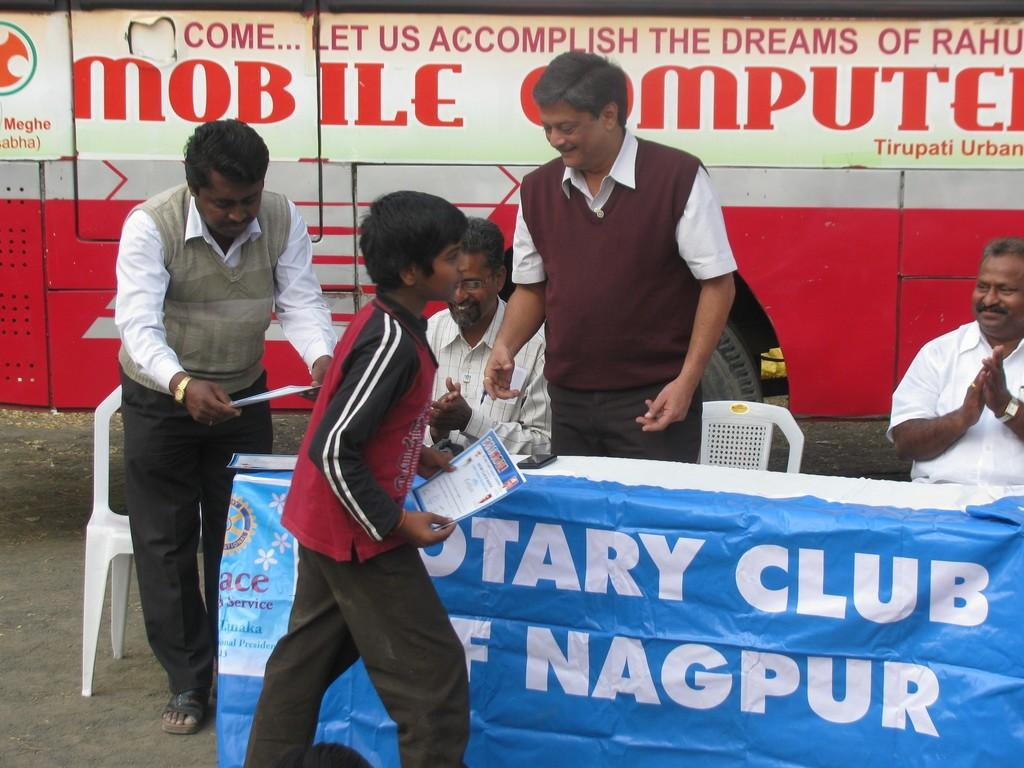What is the kid in the image doing? The kid is standing in the image and holding a certificate. Who else is present in the image? There are four persons beside the kid. What can be seen in the background of the image? There is a vehicle in the background of the image. What is written on the vehicle? The vehicle has something written on it. What type of surprise is the kid receiving from the vehicle in the image? There is no surprise present in the image; the kid is holding a certificate, and the vehicle has something written on it. How many additions are needed to make the number of persons in the image even? There are already four persons beside the kid, so no additions are needed to make the number even. 